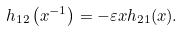<formula> <loc_0><loc_0><loc_500><loc_500>h _ { 1 2 } \left ( x ^ { - 1 } \right ) = - \varepsilon x h _ { 2 1 } ( x ) .</formula> 